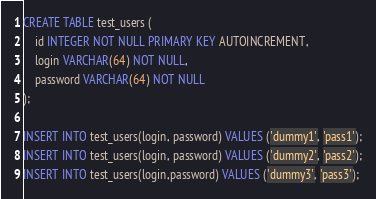Convert code to text. <code><loc_0><loc_0><loc_500><loc_500><_SQL_>CREATE TABLE test_users (
	id INTEGER NOT NULL PRIMARY KEY AUTOINCREMENT,
	login VARCHAR(64) NOT NULL,
	password VARCHAR(64) NOT NULL
);

INSERT INTO test_users(login, password) VALUES ('dummy1', 'pass1');
INSERT INTO test_users(login, password) VALUES ('dummy2', 'pass2');
INSERT INTO test_users(login,password) VALUES ('dummy3', 'pass3');</code> 